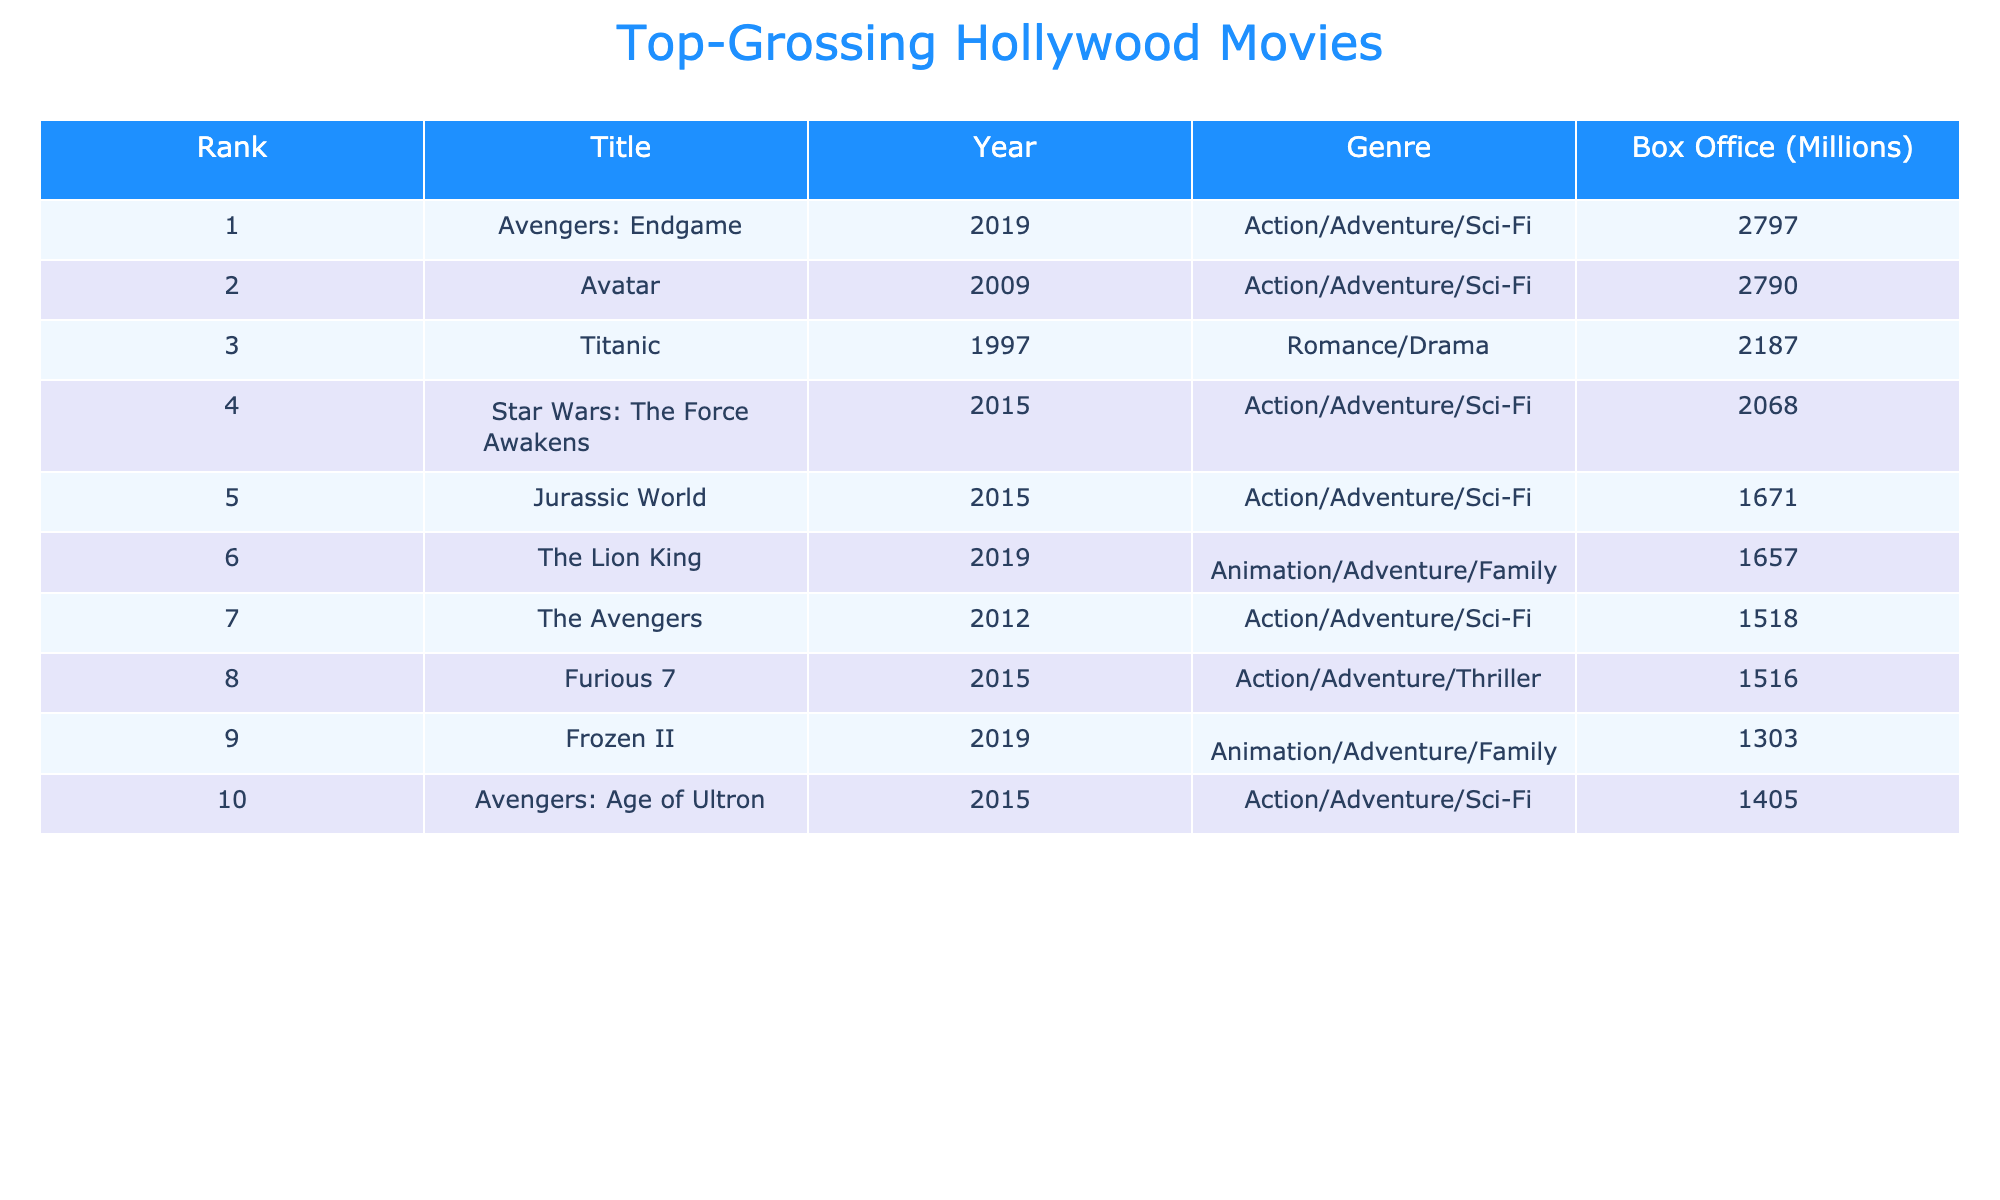What is the genre of the movie "Frozen II"? The movie "Frozen II" is listed in the table under the Genre column, which shows "Animation/Adventure/Family" as its genre.
Answer: Animation/Adventure/Family Which movie has the highest box office gross? The movie with the highest box office gross is "Avengers: Endgame," listed as the first entry in the table with a gross of 2797 million.
Answer: Avengers: Endgame How many movies in the table are categorized under the Action/Adventure/Sci-Fi genre? By reviewing the Genre column, there are five movies categorized as Action/Adventure/Sci-Fi: "Avengers: Endgame," "Avatar," "Star Wars: The Force Awakens," "Jurassic World," and "The Avengers."
Answer: 5 What is the total box office gross of all movies released in the year 2015? The movies released in 2015 are "Star Wars: The Force Awakens," "Jurassic World," "Furious 7," and "Avengers: Age of Ultron." Their box office gross sums up to 2068 + 1671 + 1516 + 1405, totaling 5860 million.
Answer: 5860 Is "Titanic" the only movie in the table categorized under Romance/Drama? Looking at the Genre column, "Titanic" is the only movie listed under Romance/Drama; hence, this statement is true.
Answer: Yes What is the average box office gross for all the movies listed? To find the average, first sum the box office gross: 2797 + 2790 + 2187 + 2068 + 1671 + 1657 + 1518 + 1516 + 1303 + 1405 = 14581 million. There are 10 movies, so the average is 14581 / 10 = 1458.1 million.
Answer: 1458.1 Which year had the highest total box office gross among its movies? The years are 2015 and 2019, both having three movies in the table. For 2015: 2068 + 1671 + 1516 + 1405 = 5860; for 2019: 2797 + 1657 + 1303 = 4757. Since 5860 (2015) is greater than 4757 (2019), 2015 had the highest total gross.
Answer: 2015 How many movies listed have a box office gross of more than 1500 million? Referring to the Box Office column, the movies with more than 1500 million gross are: "Avengers: Endgame," "Avatar," "Titanic," "Star Wars: The Force Awakens," "Jurassic World," "The Lion King," "The Avengers," and "Furious 7," totaling 8 movies.
Answer: 8 